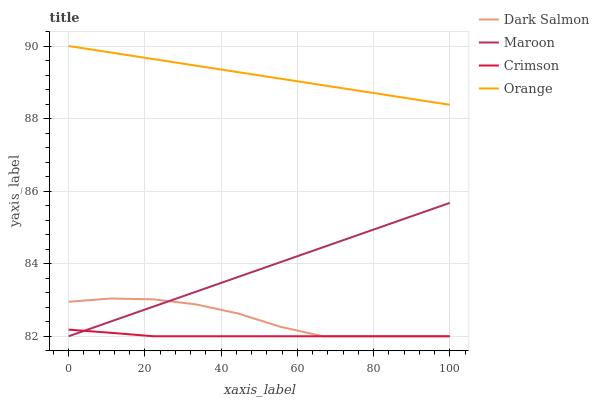Does Crimson have the minimum area under the curve?
Answer yes or no. Yes. Does Orange have the maximum area under the curve?
Answer yes or no. Yes. Does Dark Salmon have the minimum area under the curve?
Answer yes or no. No. Does Dark Salmon have the maximum area under the curve?
Answer yes or no. No. Is Maroon the smoothest?
Answer yes or no. Yes. Is Dark Salmon the roughest?
Answer yes or no. Yes. Is Orange the smoothest?
Answer yes or no. No. Is Orange the roughest?
Answer yes or no. No. Does Crimson have the lowest value?
Answer yes or no. Yes. Does Orange have the lowest value?
Answer yes or no. No. Does Orange have the highest value?
Answer yes or no. Yes. Does Dark Salmon have the highest value?
Answer yes or no. No. Is Dark Salmon less than Orange?
Answer yes or no. Yes. Is Orange greater than Dark Salmon?
Answer yes or no. Yes. Does Maroon intersect Dark Salmon?
Answer yes or no. Yes. Is Maroon less than Dark Salmon?
Answer yes or no. No. Is Maroon greater than Dark Salmon?
Answer yes or no. No. Does Dark Salmon intersect Orange?
Answer yes or no. No. 